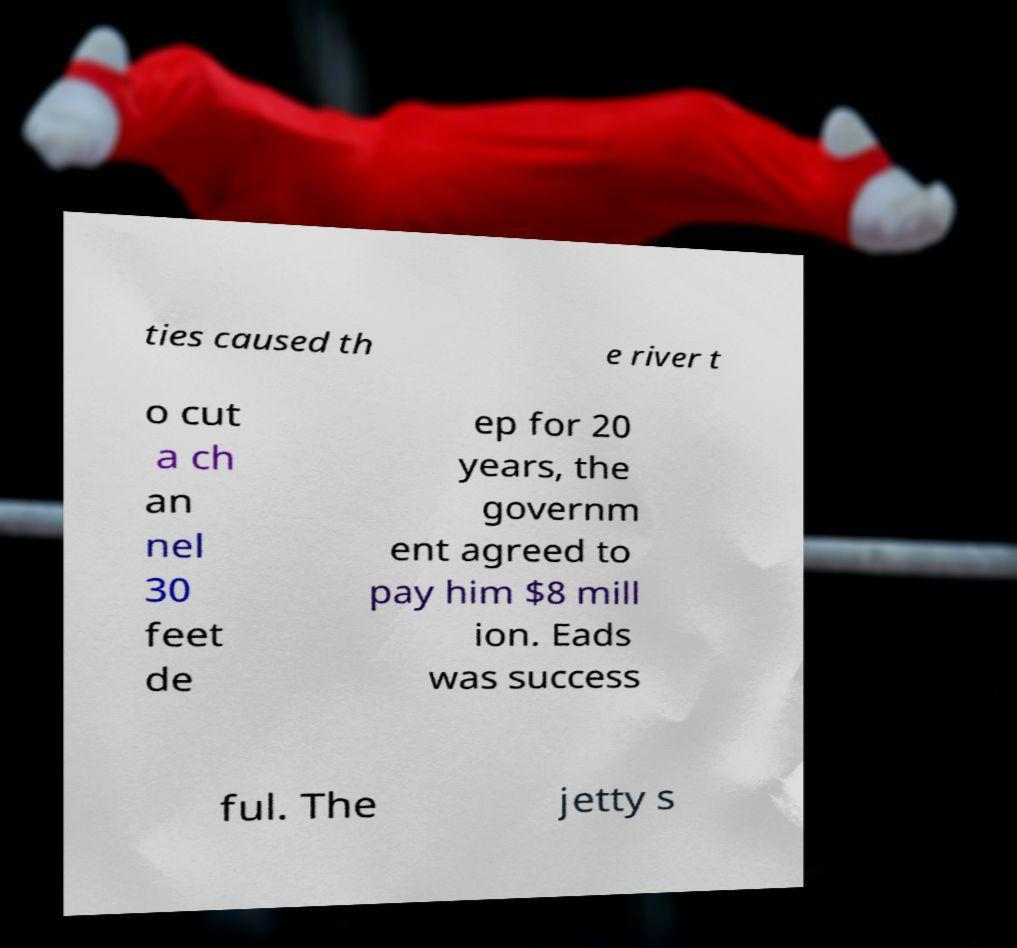Please read and relay the text visible in this image. What does it say? ties caused th e river t o cut a ch an nel 30 feet de ep for 20 years, the governm ent agreed to pay him $8 mill ion. Eads was success ful. The jetty s 